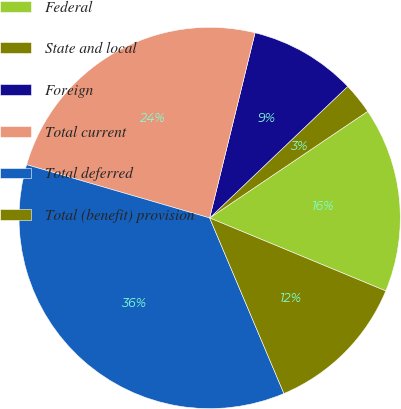Convert chart. <chart><loc_0><loc_0><loc_500><loc_500><pie_chart><fcel>Federal<fcel>State and local<fcel>Foreign<fcel>Total current<fcel>Total deferred<fcel>Total (benefit) provision<nl><fcel>15.7%<fcel>2.67%<fcel>9.06%<fcel>24.32%<fcel>35.88%<fcel>12.38%<nl></chart> 